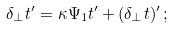Convert formula to latex. <formula><loc_0><loc_0><loc_500><loc_500>\delta _ { \perp } { t } ^ { \prime } = \kappa \Psi _ { 1 } { t } ^ { \prime } + ( \delta _ { \perp } { t } ) ^ { \prime } \, ;</formula> 